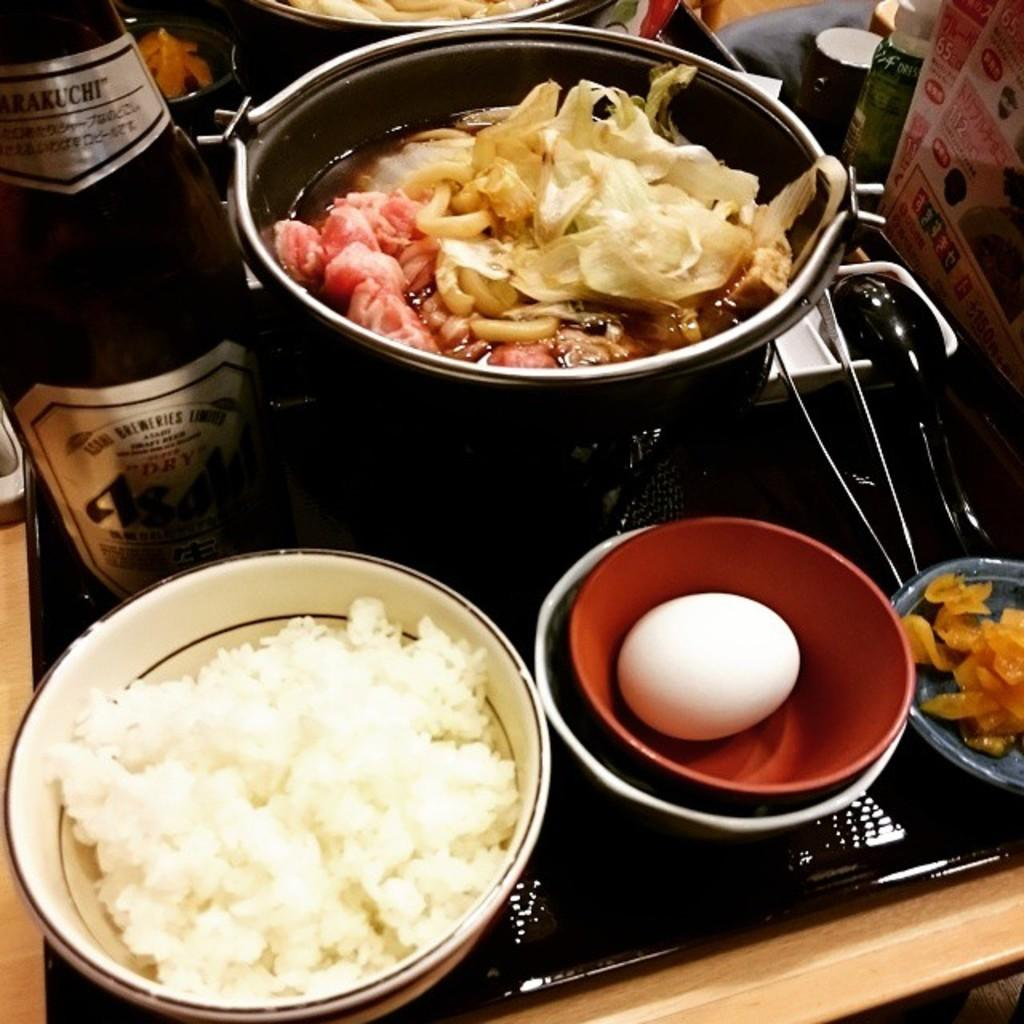<image>
Relay a brief, clear account of the picture shown. A beer with the words Asahi on the label is shown next to a bowl of rice. 